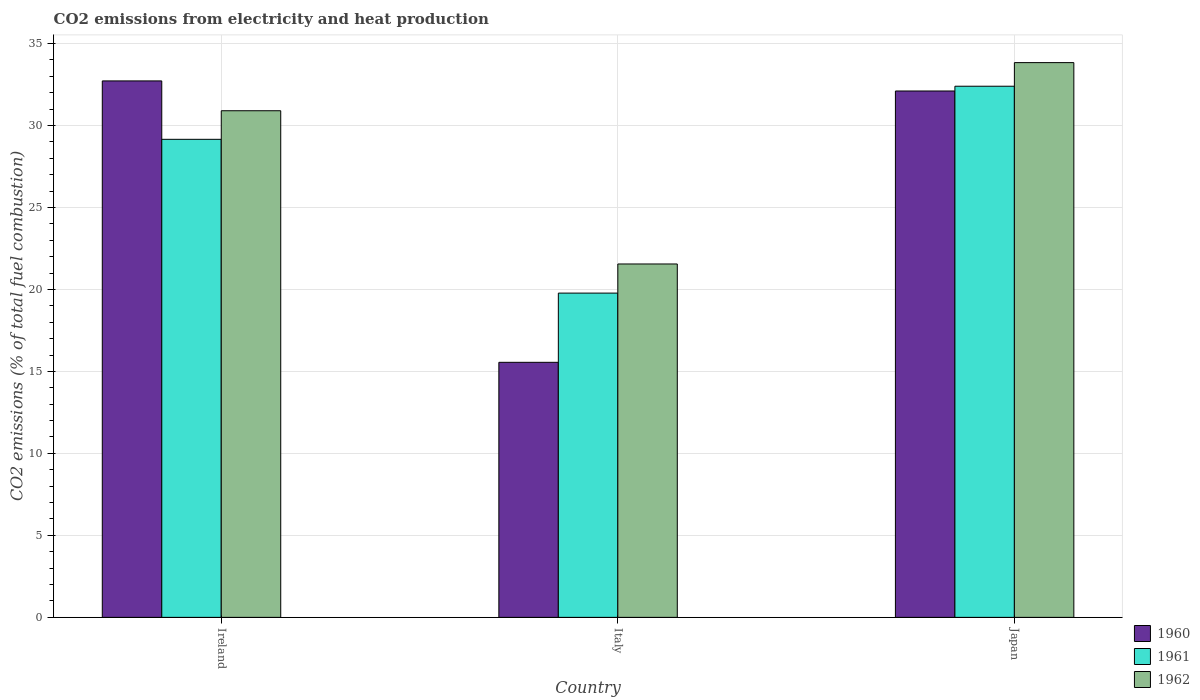How many groups of bars are there?
Your answer should be compact. 3. Are the number of bars on each tick of the X-axis equal?
Give a very brief answer. Yes. What is the amount of CO2 emitted in 1960 in Italy?
Offer a terse response. 15.55. Across all countries, what is the maximum amount of CO2 emitted in 1961?
Keep it short and to the point. 32.39. Across all countries, what is the minimum amount of CO2 emitted in 1962?
Offer a terse response. 21.55. What is the total amount of CO2 emitted in 1961 in the graph?
Keep it short and to the point. 81.32. What is the difference between the amount of CO2 emitted in 1962 in Ireland and that in Italy?
Ensure brevity in your answer.  9.35. What is the difference between the amount of CO2 emitted in 1960 in Japan and the amount of CO2 emitted in 1961 in Ireland?
Ensure brevity in your answer.  2.95. What is the average amount of CO2 emitted in 1961 per country?
Your answer should be compact. 27.11. What is the difference between the amount of CO2 emitted of/in 1961 and amount of CO2 emitted of/in 1962 in Ireland?
Give a very brief answer. -1.74. In how many countries, is the amount of CO2 emitted in 1960 greater than 32 %?
Your response must be concise. 2. What is the ratio of the amount of CO2 emitted in 1961 in Ireland to that in Italy?
Ensure brevity in your answer.  1.47. Is the difference between the amount of CO2 emitted in 1961 in Ireland and Italy greater than the difference between the amount of CO2 emitted in 1962 in Ireland and Italy?
Offer a very short reply. Yes. What is the difference between the highest and the second highest amount of CO2 emitted in 1960?
Your answer should be compact. 0.61. What is the difference between the highest and the lowest amount of CO2 emitted in 1961?
Make the answer very short. 12.62. What does the 1st bar from the right in Italy represents?
Your answer should be compact. 1962. How many countries are there in the graph?
Provide a short and direct response. 3. Does the graph contain any zero values?
Make the answer very short. No. Does the graph contain grids?
Offer a very short reply. Yes. Where does the legend appear in the graph?
Give a very brief answer. Bottom right. What is the title of the graph?
Your response must be concise. CO2 emissions from electricity and heat production. Does "1977" appear as one of the legend labels in the graph?
Provide a succinct answer. No. What is the label or title of the Y-axis?
Keep it short and to the point. CO2 emissions (% of total fuel combustion). What is the CO2 emissions (% of total fuel combustion) of 1960 in Ireland?
Provide a short and direct response. 32.72. What is the CO2 emissions (% of total fuel combustion) of 1961 in Ireland?
Your response must be concise. 29.15. What is the CO2 emissions (% of total fuel combustion) in 1962 in Ireland?
Your response must be concise. 30.9. What is the CO2 emissions (% of total fuel combustion) of 1960 in Italy?
Give a very brief answer. 15.55. What is the CO2 emissions (% of total fuel combustion) in 1961 in Italy?
Your answer should be very brief. 19.78. What is the CO2 emissions (% of total fuel combustion) of 1962 in Italy?
Ensure brevity in your answer.  21.55. What is the CO2 emissions (% of total fuel combustion) of 1960 in Japan?
Ensure brevity in your answer.  32.1. What is the CO2 emissions (% of total fuel combustion) of 1961 in Japan?
Make the answer very short. 32.39. What is the CO2 emissions (% of total fuel combustion) of 1962 in Japan?
Your answer should be very brief. 33.83. Across all countries, what is the maximum CO2 emissions (% of total fuel combustion) in 1960?
Provide a short and direct response. 32.72. Across all countries, what is the maximum CO2 emissions (% of total fuel combustion) in 1961?
Offer a very short reply. 32.39. Across all countries, what is the maximum CO2 emissions (% of total fuel combustion) in 1962?
Keep it short and to the point. 33.83. Across all countries, what is the minimum CO2 emissions (% of total fuel combustion) of 1960?
Your answer should be compact. 15.55. Across all countries, what is the minimum CO2 emissions (% of total fuel combustion) in 1961?
Your answer should be compact. 19.78. Across all countries, what is the minimum CO2 emissions (% of total fuel combustion) in 1962?
Make the answer very short. 21.55. What is the total CO2 emissions (% of total fuel combustion) of 1960 in the graph?
Provide a short and direct response. 80.37. What is the total CO2 emissions (% of total fuel combustion) in 1961 in the graph?
Give a very brief answer. 81.32. What is the total CO2 emissions (% of total fuel combustion) in 1962 in the graph?
Give a very brief answer. 86.28. What is the difference between the CO2 emissions (% of total fuel combustion) in 1960 in Ireland and that in Italy?
Your response must be concise. 17.16. What is the difference between the CO2 emissions (% of total fuel combustion) of 1961 in Ireland and that in Italy?
Offer a terse response. 9.38. What is the difference between the CO2 emissions (% of total fuel combustion) of 1962 in Ireland and that in Italy?
Give a very brief answer. 9.35. What is the difference between the CO2 emissions (% of total fuel combustion) of 1960 in Ireland and that in Japan?
Keep it short and to the point. 0.61. What is the difference between the CO2 emissions (% of total fuel combustion) in 1961 in Ireland and that in Japan?
Make the answer very short. -3.24. What is the difference between the CO2 emissions (% of total fuel combustion) of 1962 in Ireland and that in Japan?
Your response must be concise. -2.94. What is the difference between the CO2 emissions (% of total fuel combustion) of 1960 in Italy and that in Japan?
Your answer should be very brief. -16.55. What is the difference between the CO2 emissions (% of total fuel combustion) in 1961 in Italy and that in Japan?
Make the answer very short. -12.62. What is the difference between the CO2 emissions (% of total fuel combustion) of 1962 in Italy and that in Japan?
Offer a very short reply. -12.28. What is the difference between the CO2 emissions (% of total fuel combustion) of 1960 in Ireland and the CO2 emissions (% of total fuel combustion) of 1961 in Italy?
Offer a very short reply. 12.94. What is the difference between the CO2 emissions (% of total fuel combustion) in 1960 in Ireland and the CO2 emissions (% of total fuel combustion) in 1962 in Italy?
Provide a short and direct response. 11.16. What is the difference between the CO2 emissions (% of total fuel combustion) of 1961 in Ireland and the CO2 emissions (% of total fuel combustion) of 1962 in Italy?
Make the answer very short. 7.6. What is the difference between the CO2 emissions (% of total fuel combustion) of 1960 in Ireland and the CO2 emissions (% of total fuel combustion) of 1961 in Japan?
Offer a very short reply. 0.32. What is the difference between the CO2 emissions (% of total fuel combustion) of 1960 in Ireland and the CO2 emissions (% of total fuel combustion) of 1962 in Japan?
Your response must be concise. -1.12. What is the difference between the CO2 emissions (% of total fuel combustion) in 1961 in Ireland and the CO2 emissions (% of total fuel combustion) in 1962 in Japan?
Provide a succinct answer. -4.68. What is the difference between the CO2 emissions (% of total fuel combustion) in 1960 in Italy and the CO2 emissions (% of total fuel combustion) in 1961 in Japan?
Your answer should be very brief. -16.84. What is the difference between the CO2 emissions (% of total fuel combustion) in 1960 in Italy and the CO2 emissions (% of total fuel combustion) in 1962 in Japan?
Offer a very short reply. -18.28. What is the difference between the CO2 emissions (% of total fuel combustion) of 1961 in Italy and the CO2 emissions (% of total fuel combustion) of 1962 in Japan?
Your answer should be very brief. -14.06. What is the average CO2 emissions (% of total fuel combustion) of 1960 per country?
Keep it short and to the point. 26.79. What is the average CO2 emissions (% of total fuel combustion) of 1961 per country?
Your answer should be compact. 27.11. What is the average CO2 emissions (% of total fuel combustion) of 1962 per country?
Offer a very short reply. 28.76. What is the difference between the CO2 emissions (% of total fuel combustion) in 1960 and CO2 emissions (% of total fuel combustion) in 1961 in Ireland?
Keep it short and to the point. 3.56. What is the difference between the CO2 emissions (% of total fuel combustion) of 1960 and CO2 emissions (% of total fuel combustion) of 1962 in Ireland?
Offer a terse response. 1.82. What is the difference between the CO2 emissions (% of total fuel combustion) in 1961 and CO2 emissions (% of total fuel combustion) in 1962 in Ireland?
Make the answer very short. -1.74. What is the difference between the CO2 emissions (% of total fuel combustion) in 1960 and CO2 emissions (% of total fuel combustion) in 1961 in Italy?
Give a very brief answer. -4.22. What is the difference between the CO2 emissions (% of total fuel combustion) in 1960 and CO2 emissions (% of total fuel combustion) in 1962 in Italy?
Ensure brevity in your answer.  -6. What is the difference between the CO2 emissions (% of total fuel combustion) of 1961 and CO2 emissions (% of total fuel combustion) of 1962 in Italy?
Keep it short and to the point. -1.78. What is the difference between the CO2 emissions (% of total fuel combustion) of 1960 and CO2 emissions (% of total fuel combustion) of 1961 in Japan?
Your answer should be very brief. -0.29. What is the difference between the CO2 emissions (% of total fuel combustion) of 1960 and CO2 emissions (% of total fuel combustion) of 1962 in Japan?
Offer a very short reply. -1.73. What is the difference between the CO2 emissions (% of total fuel combustion) in 1961 and CO2 emissions (% of total fuel combustion) in 1962 in Japan?
Provide a short and direct response. -1.44. What is the ratio of the CO2 emissions (% of total fuel combustion) of 1960 in Ireland to that in Italy?
Your response must be concise. 2.1. What is the ratio of the CO2 emissions (% of total fuel combustion) in 1961 in Ireland to that in Italy?
Your answer should be compact. 1.47. What is the ratio of the CO2 emissions (% of total fuel combustion) of 1962 in Ireland to that in Italy?
Keep it short and to the point. 1.43. What is the ratio of the CO2 emissions (% of total fuel combustion) in 1960 in Ireland to that in Japan?
Make the answer very short. 1.02. What is the ratio of the CO2 emissions (% of total fuel combustion) in 1961 in Ireland to that in Japan?
Your answer should be compact. 0.9. What is the ratio of the CO2 emissions (% of total fuel combustion) in 1962 in Ireland to that in Japan?
Make the answer very short. 0.91. What is the ratio of the CO2 emissions (% of total fuel combustion) of 1960 in Italy to that in Japan?
Make the answer very short. 0.48. What is the ratio of the CO2 emissions (% of total fuel combustion) in 1961 in Italy to that in Japan?
Provide a succinct answer. 0.61. What is the ratio of the CO2 emissions (% of total fuel combustion) in 1962 in Italy to that in Japan?
Your answer should be compact. 0.64. What is the difference between the highest and the second highest CO2 emissions (% of total fuel combustion) of 1960?
Your answer should be very brief. 0.61. What is the difference between the highest and the second highest CO2 emissions (% of total fuel combustion) of 1961?
Your answer should be compact. 3.24. What is the difference between the highest and the second highest CO2 emissions (% of total fuel combustion) of 1962?
Your answer should be compact. 2.94. What is the difference between the highest and the lowest CO2 emissions (% of total fuel combustion) of 1960?
Make the answer very short. 17.16. What is the difference between the highest and the lowest CO2 emissions (% of total fuel combustion) of 1961?
Your response must be concise. 12.62. What is the difference between the highest and the lowest CO2 emissions (% of total fuel combustion) in 1962?
Keep it short and to the point. 12.28. 